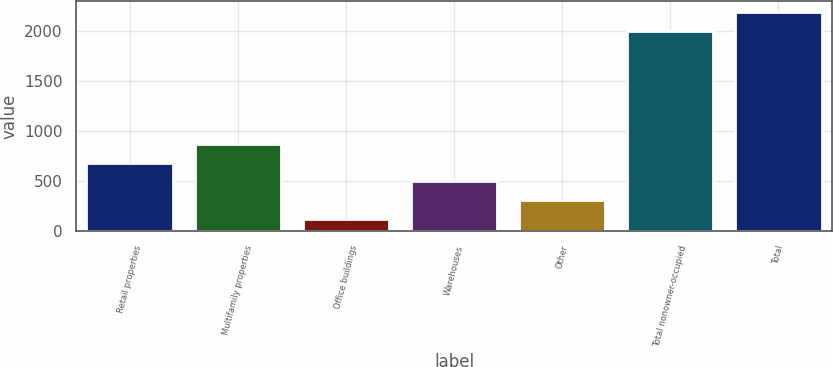Convert chart. <chart><loc_0><loc_0><loc_500><loc_500><bar_chart><fcel>Retail properties<fcel>Multifamily properties<fcel>Office buildings<fcel>Warehouses<fcel>Other<fcel>Total nonowner-occupied<fcel>Total<nl><fcel>685.1<fcel>873.8<fcel>119<fcel>496.4<fcel>307.7<fcel>2006<fcel>2194.7<nl></chart> 